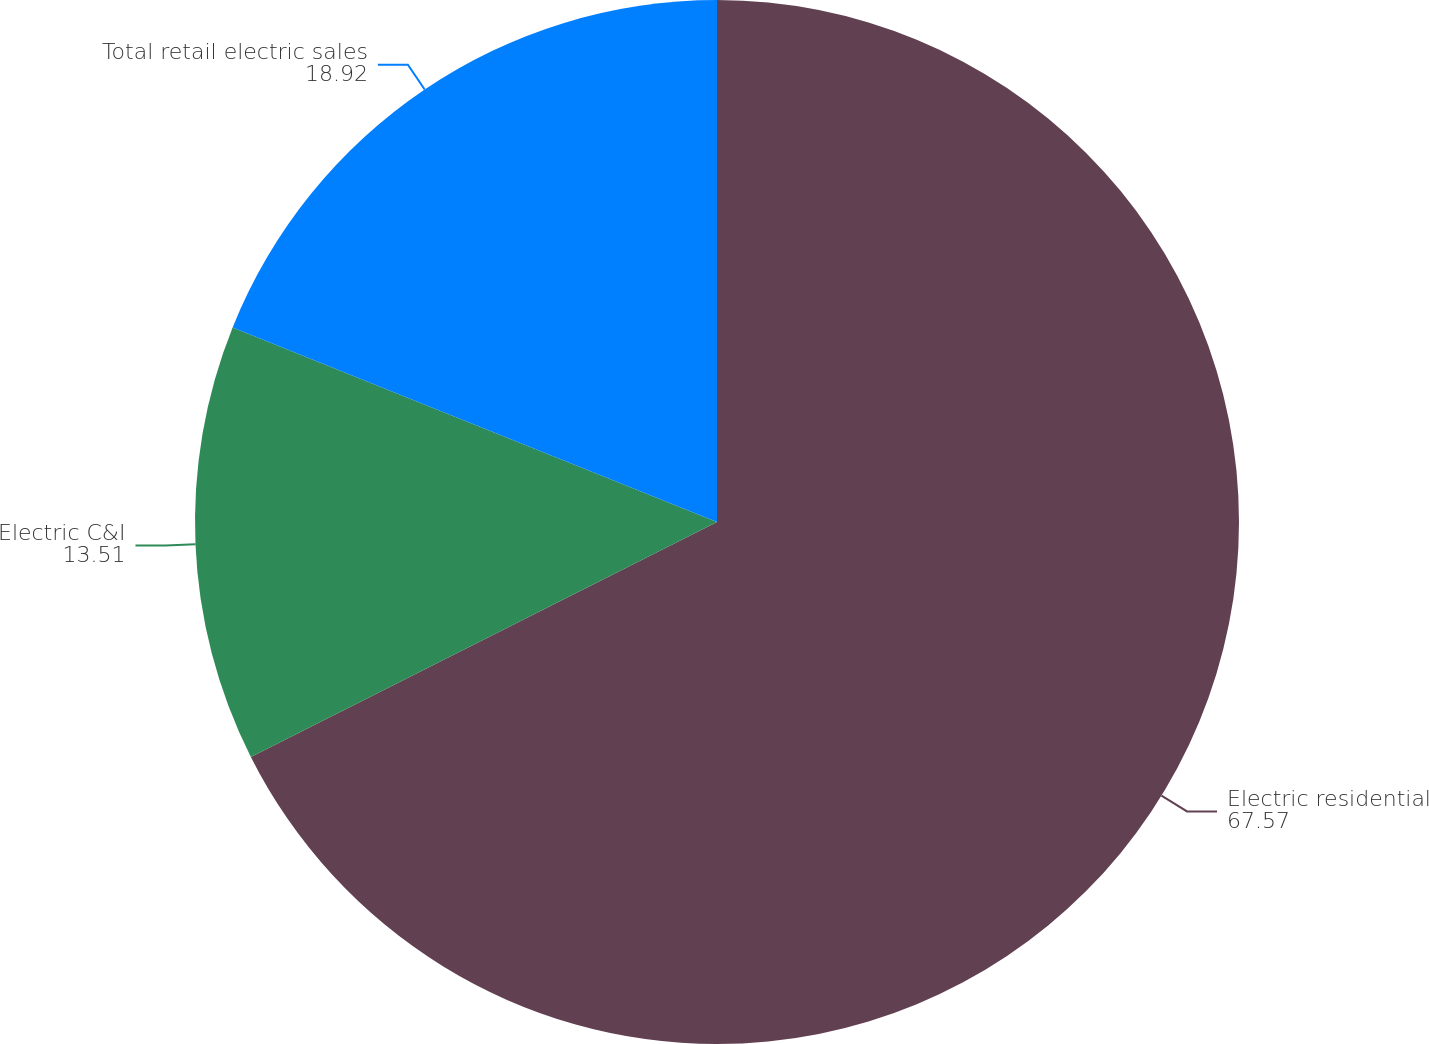Convert chart to OTSL. <chart><loc_0><loc_0><loc_500><loc_500><pie_chart><fcel>Electric residential<fcel>Electric C&I<fcel>Total retail electric sales<nl><fcel>67.57%<fcel>13.51%<fcel>18.92%<nl></chart> 